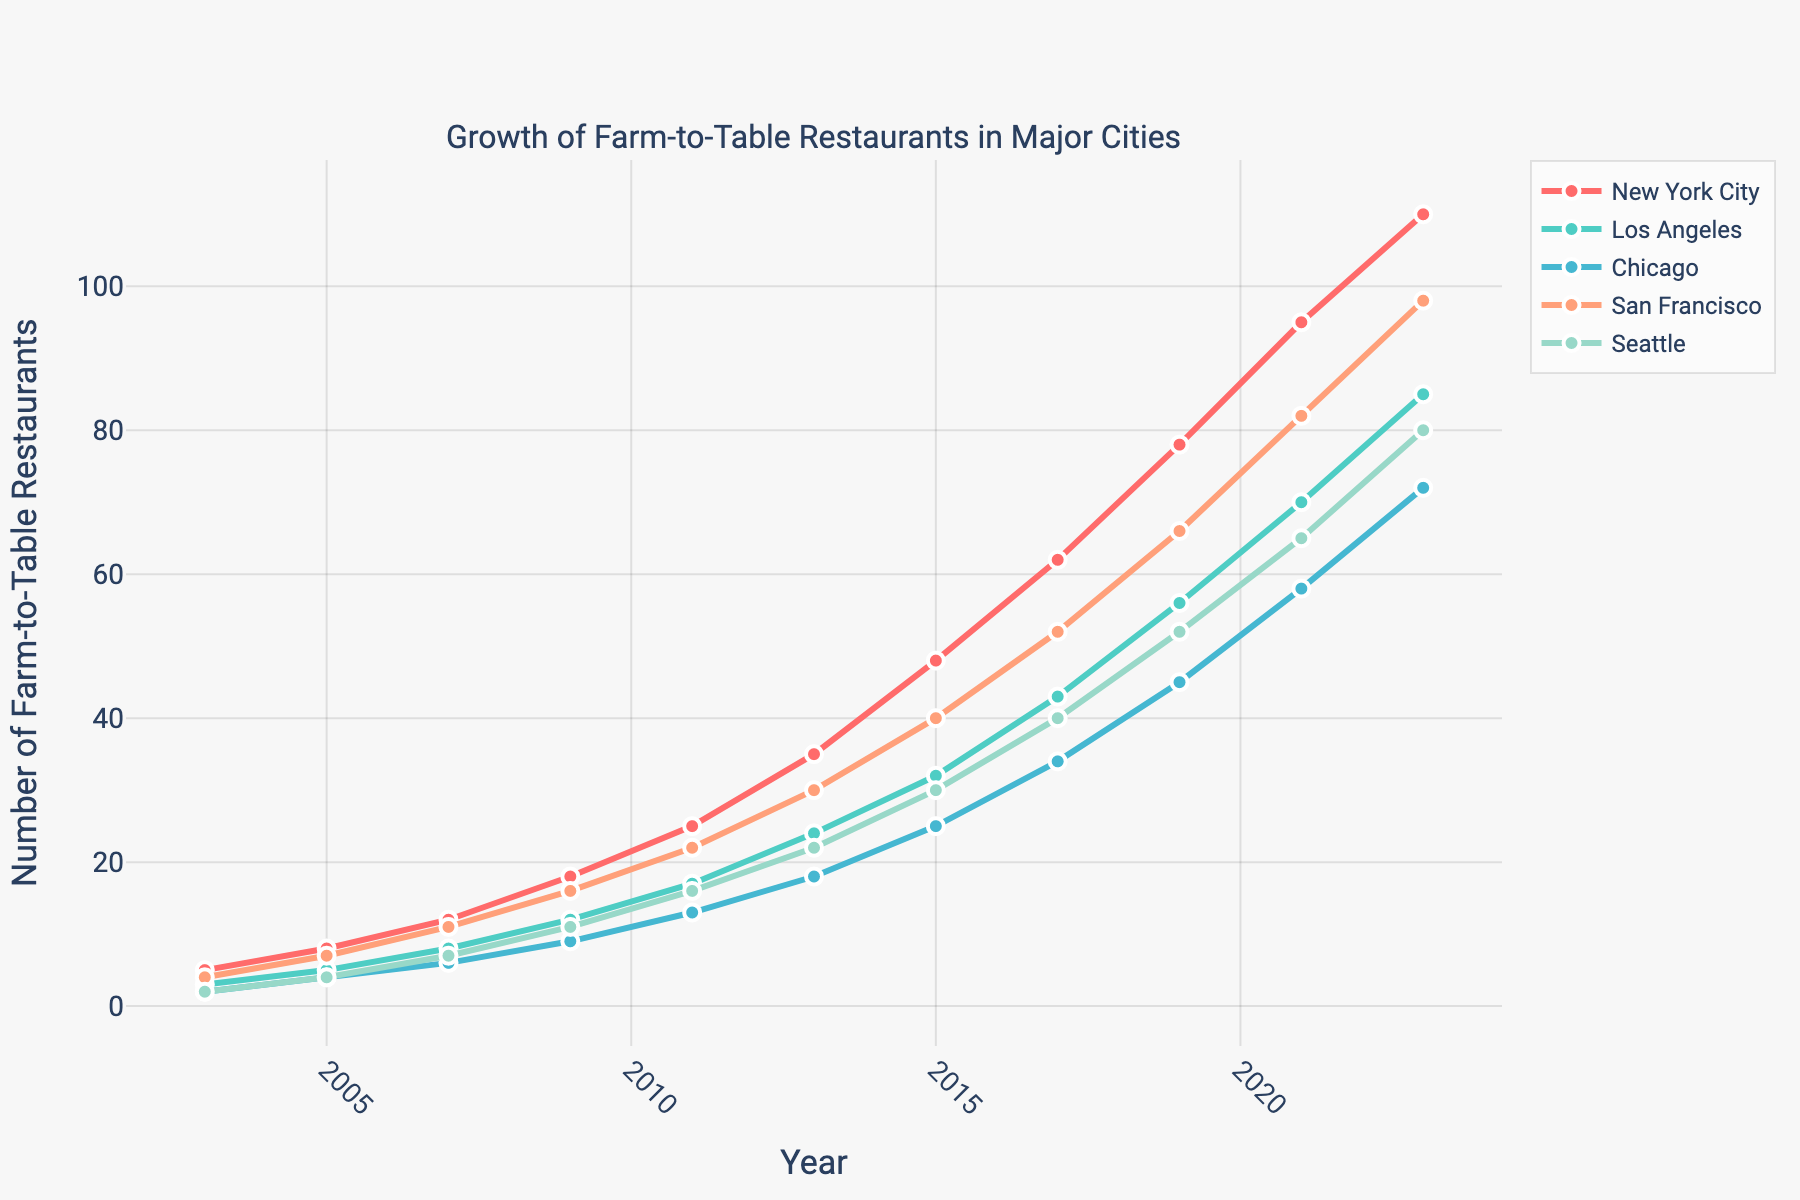What city had the most farm-to-table restaurants in 2023? Look at the data points for the year 2023 across the cities and identify the highest value
Answer: New York City In 2015, how many more farm-to-table restaurants did New York City have compared to Chicago? Subtract the number of restaurants in Chicago from New York City in 2015 (48 - 25)
Answer: 23 Between 2003 and 2023, which city saw the largest increase in the number of farm-to-table restaurants? Calculate the difference from 2023 to 2003 for each city, and identify the largest increase
Answer: New York City How does the growth trend of Los Angeles compare to San Francisco over the 20-year period? Compare the slopes of the lines representing Los Angeles and San Francisco and note which one has a steeper slope more frequently
Answer: San Francisco has a steeper growth trend What is the average number of farm-to-table restaurants in Seattle from 2003 to 2023? Sum the data points for Seattle from 2003 to 2023 and divide by the number of years (2+4+7+11+16+22+30+40+52+65+80) / 11
Answer: 29.18 In which year did New York City surpass 50 farm-to-table restaurants? Find the first year in the data where New York City had more than 50 restaurants
Answer: 2017 Which city had the smallest number of farm-to-table restaurants in 2007? Look at the data points for the year 2007 and identify the smallest value
Answer: Chicago How many more farm-to-table restaurants were there in New York City compared to Seattle in 2023? Subtract the number of restaurants in Seattle from New York City in 2023 (110 - 80)
Answer: 30 What is the trend of farm-to-table restaurant growth in Chicago between 2009 and 2015? Observe the data points for Chicago between 2009 and 2015 and describe the pattern (9 in 2009 to 25 in 2015)
Answer: Increasing In 2019, which two cities had the closest number of farm-to-table restaurants? Compare the number of restaurants for each pair of cities in 2019 and identify the pair with the closest numbers
Answer: San Francisco and Seattle 